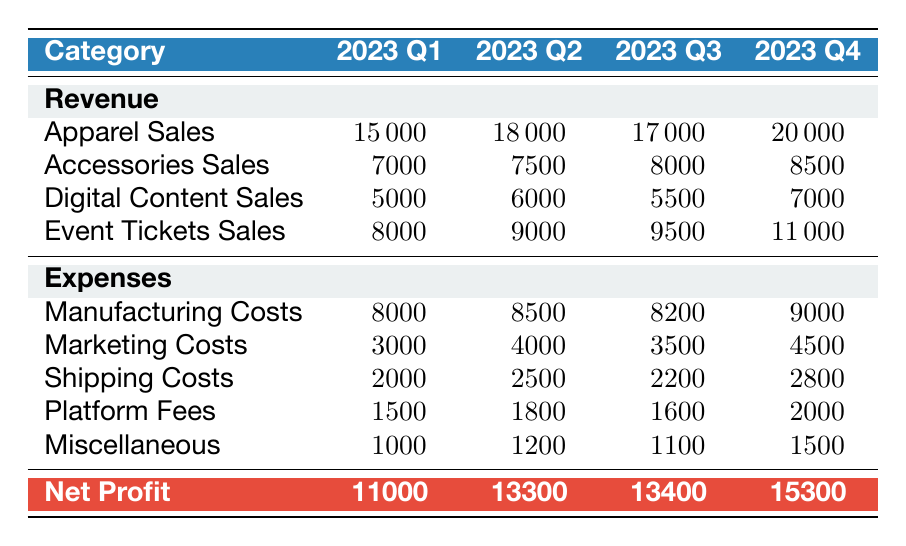What was the total revenue for 2023 Q2? To find the total revenue for Q2, we add up all revenue categories: Apparel Sales (18000) + Accessories Sales (7500) + Digital Content Sales (6000) + Event Tickets Sales (9000). This gives us a total of 18000 + 7500 + 6000 + 9000 =  34500.
Answer: 34500 What is the net profit for 2023 Q4? The net profit for Q4 is directly stated in the table as 15300.
Answer: 15300 Did the marketing costs increase from Q1 to Q2? Comparing Q1 marketing costs (3000) with Q2 marketing costs (4000), we see that Q2 is higher. Thus, the statement is true.
Answer: Yes What is the average net profit over the four quarters? To calculate the average net profit, we first sum the net profits for all quarters: 11000 + 13300 + 13400 + 15300 = 63000. Then, we divide by the number of quarters (4), resulting in 63000 / 4 = 15750.
Answer: 15750 Which quarter had the highest apparel sales? Looking at the apparel sales for each quarter, Q1 had 15000, Q2 had 18000, Q3 had 17000, and Q4 had 20000. The highest was in Q4.
Answer: Q4 What are the total expenses for 2023 Q3? The total expenses for Q3 can be calculated by adding up all expense categories: Manufacturing Costs (8200) + Marketing Costs (3500) + Shipping Costs (2200) + Platform Fees (1600) + Miscellaneous (1100). So, 8200 + 3500 + 2200 + 1600 + 1100 = 22600.
Answer: 22600 Is the revenue from digital content sales lower in Q3 than in Q2? In Q3, digital content sales amount to 5500, while in Q2, they are 6000. Since 5500 is less than 6000, the statement is true.
Answer: Yes Which quarter had the least amount of total expenses? We compare the total expenses across the quarters: For Q1 it is 8000 + 3000 + 2000 + 1500 + 1000 = 15500; for Q2 it is 8500 + 4000 + 2500 + 1800 + 1200 = 18000; for Q3 it is 8200 + 3500 + 2200 + 1600 + 1100 = 22600; and for Q4 it is 9000 + 4500 + 2800 + 2000 + 1500 = 19800. The least is in Q1 with 15500.
Answer: Q1 